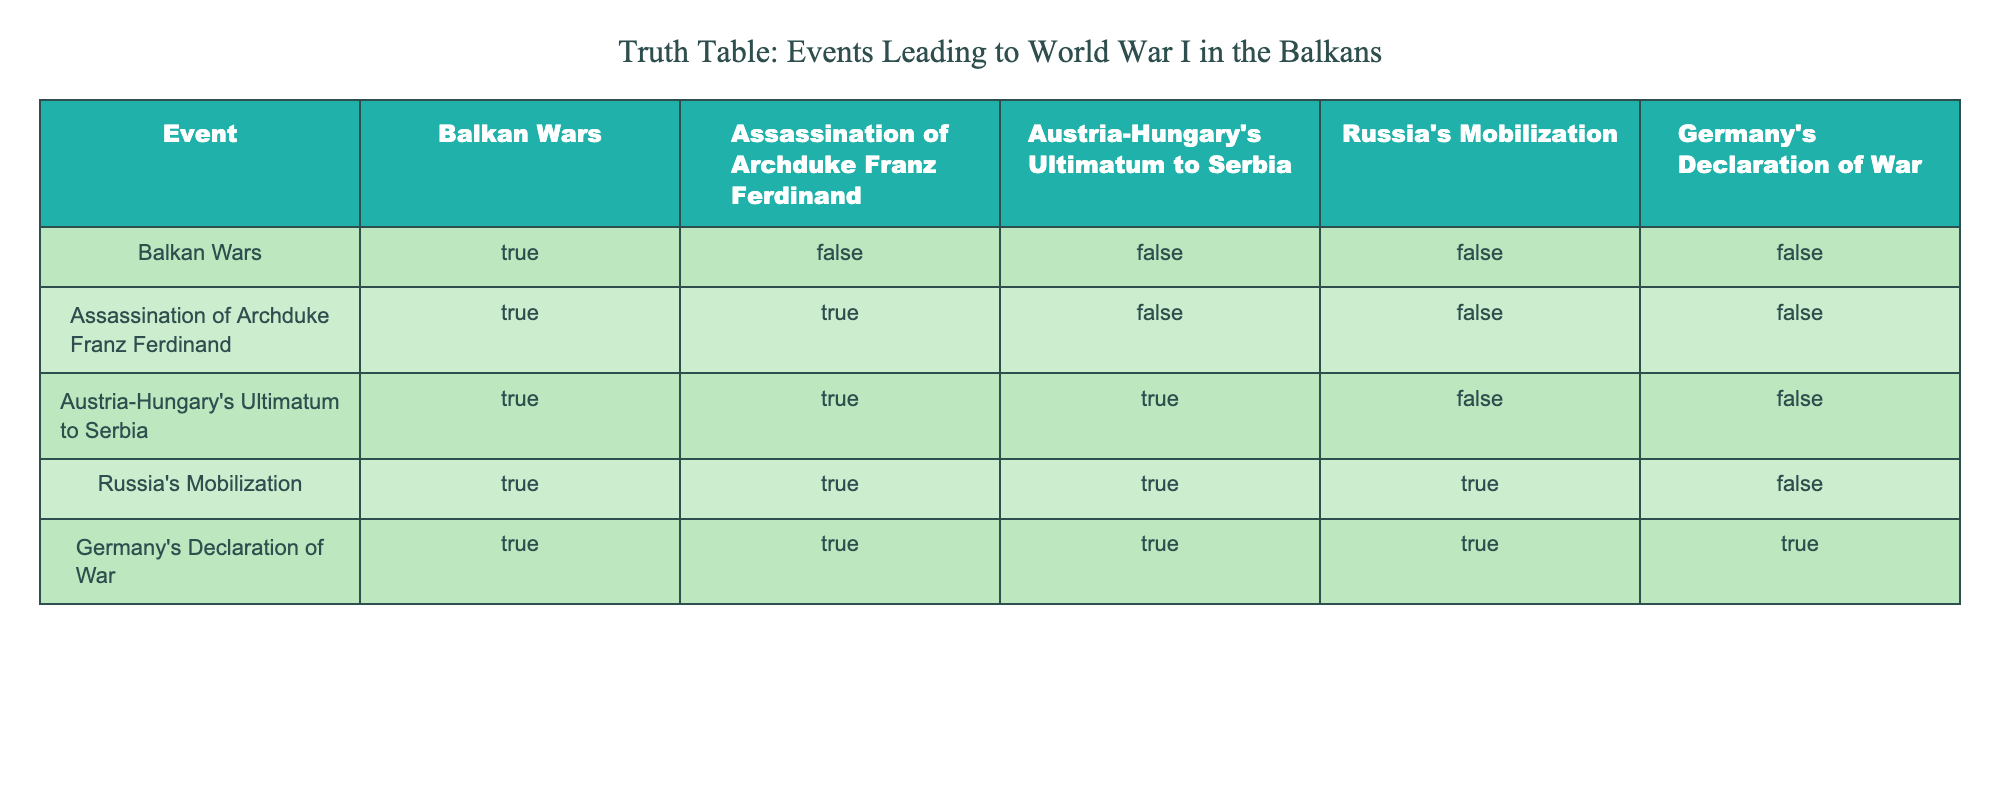What events are true for the Balkan Wars? According to the table, under the column for "Balkan Wars," the only event marked as true is itself. This means that the Balkan Wars lead to further events, but no other events are marked true in relation to just this event.
Answer: Only the Balkan Wars are true Did the Assassination of Archduke Franz Ferdinand lead to Austria-Hungary's Ultimatum to Serbia? In the table, under the column for "Assassination of Archduke Franz Ferdinand," the entry corresponding to "Austria-Hungary's Ultimatum to Serbia" is marked as false. Thus, the assassination did not directly lead to this ultimatum.
Answer: No Was Russia's Mobilization a direct result of the Assassination of Archduke Franz Ferdinand? The table shows that the column for "Assassination of Archduke Franz Ferdinand" with respect to "Russia's Mobilization" is false, indicating that the assassination did not directly cause Russia to mobilize.
Answer: No How many events are true for Germany's Declaration of War? By looking at the "Germany's Declaration of War" column, all previous events are marked as true. This means that there are five true events leading to Germany's Declaration of War. Summing these up gives a total of five events.
Answer: 5 Which event did not lead to Russia's Mobilization? In the table, looking at the "Russia's Mobilization" section, it can be seen that the only event that is false is "Austria-Hungary's Ultimatum to Serbia." Hence, this event did not contribute to Russia's Mobilization.
Answer: Austria-Hungary's Ultimatum to Serbia What is the logical relationship chain from the Balkan Wars to Germany's Declaration of War? To find this relationship, we look at the truth values from the "Balkan Wars" through to "Germany's Declaration of War." The Balkan Wars lead to the Assassination, which leads to the Ultimatum, then to Russia's Mobilization, culminating in Germany's Declaration of War. The logical progression is clearly true across all events.
Answer: The chain is: Balkan Wars -> Assassination -> Ultimatum -> Russia's Mobilization -> Germany's Declaration of War Is it true that the Assassination of Archduke Franz Ferdinand caused all subsequent events listed? In the table, only the first two events after the assassination (itself and the ultimatum) are true. The subsequent events do not all directly stem from the assassination; it cannot be concluded that it caused every listed event.
Answer: No How many events were directly impacted by Austria-Hungary's Ultimatum to Serbia? Looking at the table, "Austria-Hungary's Ultimatum to Serbia" indicates that it leads to the Assassination and also affects Russia's Mobilization, but does not directly initiate Germany's Declaration of War. Therefore, three events can be counted as directly impacted.
Answer: 3 